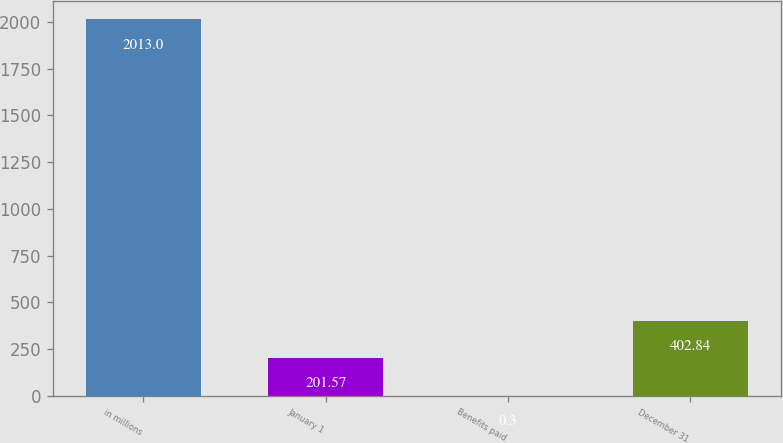<chart> <loc_0><loc_0><loc_500><loc_500><bar_chart><fcel>in millions<fcel>January 1<fcel>Benefits paid<fcel>December 31<nl><fcel>2013<fcel>201.57<fcel>0.3<fcel>402.84<nl></chart> 